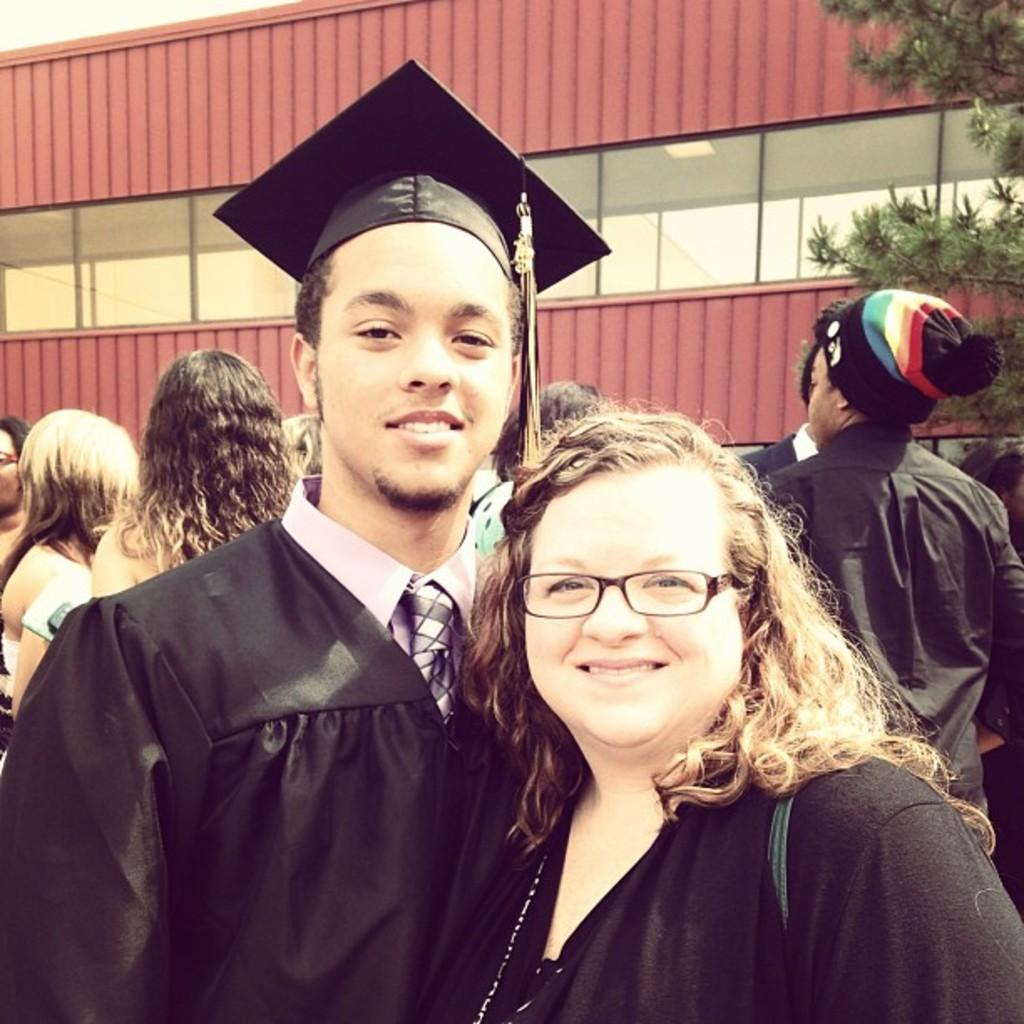What can be seen in the image? There is a group of people in the image. Can you describe any specific individuals in the group? Yes, there is a woman in the image. What is the woman wearing? The woman is wearing spectacles. What can be seen in the background of the image? There is a tree and a building in the background of the image. Where is the throne located in the image? There is no throne present in the image. What type of cloud can be seen in the image? There is no cloud visible in the image. 